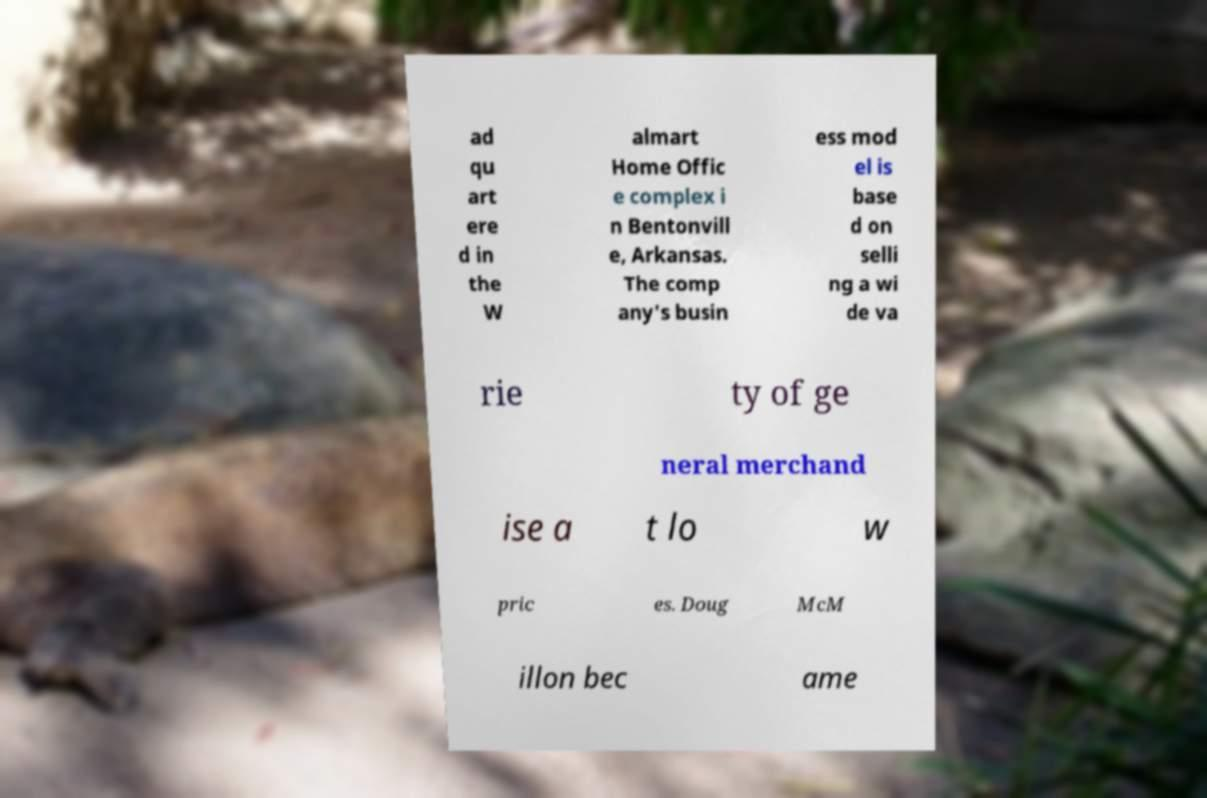What messages or text are displayed in this image? I need them in a readable, typed format. ad qu art ere d in the W almart Home Offic e complex i n Bentonvill e, Arkansas. The comp any's busin ess mod el is base d on selli ng a wi de va rie ty of ge neral merchand ise a t lo w pric es. Doug McM illon bec ame 